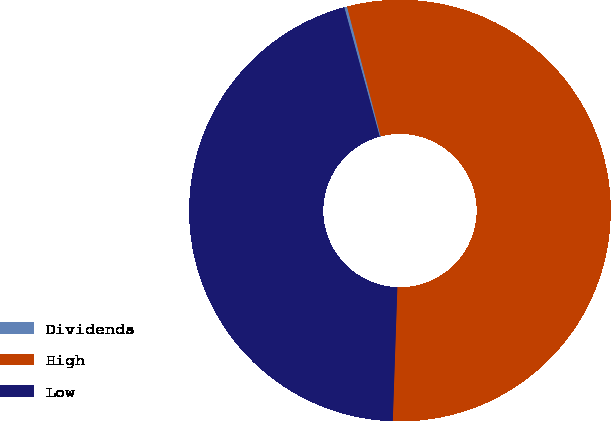<chart> <loc_0><loc_0><loc_500><loc_500><pie_chart><fcel>Dividends<fcel>High<fcel>Low<nl><fcel>0.22%<fcel>54.58%<fcel>45.2%<nl></chart> 